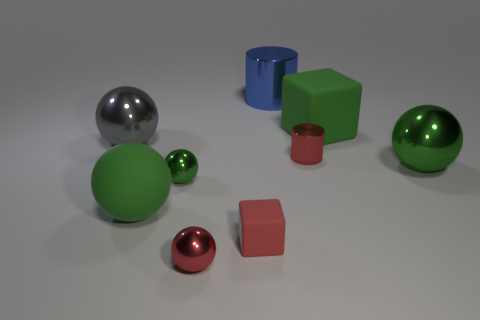What number of big green things have the same shape as the blue metal object?
Ensure brevity in your answer.  0. The block left of the rubber cube that is right of the big shiny cylinder is made of what material?
Keep it short and to the point. Rubber. The small shiny object that is the same color as the tiny shiny cylinder is what shape?
Provide a short and direct response. Sphere. Is there a big blue cylinder that has the same material as the gray ball?
Your response must be concise. Yes. The large blue thing has what shape?
Your response must be concise. Cylinder. What number of blue things are there?
Your answer should be compact. 1. What color is the big object that is behind the large green matte object behind the large green rubber sphere?
Offer a terse response. Blue. The cylinder that is the same size as the red shiny sphere is what color?
Make the answer very short. Red. Are there any large spheres that have the same color as the tiny block?
Your answer should be compact. No. Are there any green matte cylinders?
Keep it short and to the point. No. 